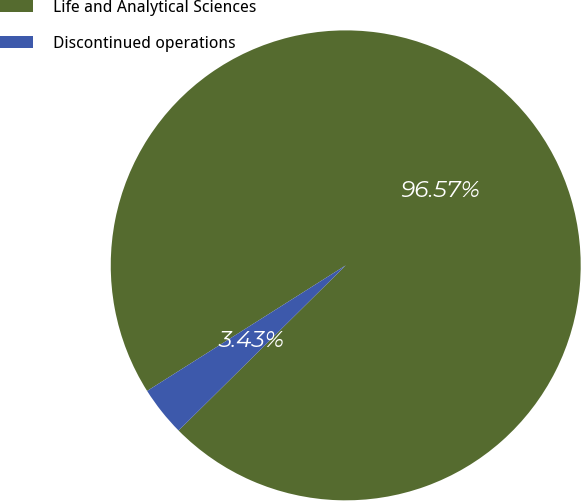Convert chart. <chart><loc_0><loc_0><loc_500><loc_500><pie_chart><fcel>Life and Analytical Sciences<fcel>Discontinued operations<nl><fcel>96.57%<fcel>3.43%<nl></chart> 